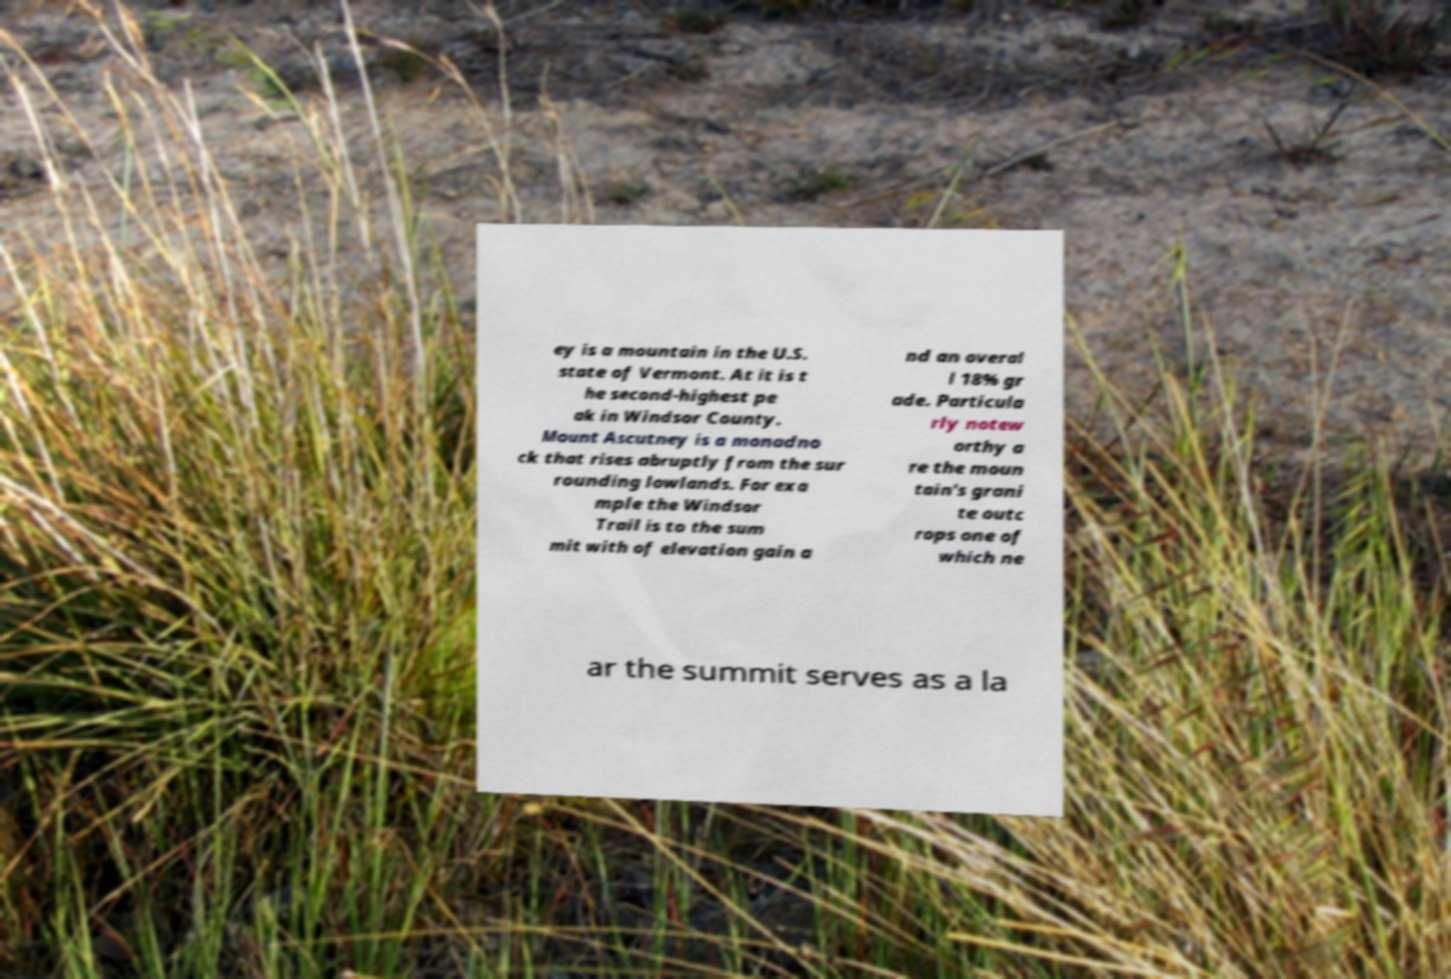Please identify and transcribe the text found in this image. ey is a mountain in the U.S. state of Vermont. At it is t he second-highest pe ak in Windsor County. Mount Ascutney is a monadno ck that rises abruptly from the sur rounding lowlands. For exa mple the Windsor Trail is to the sum mit with of elevation gain a nd an overal l 18% gr ade. Particula rly notew orthy a re the moun tain's grani te outc rops one of which ne ar the summit serves as a la 